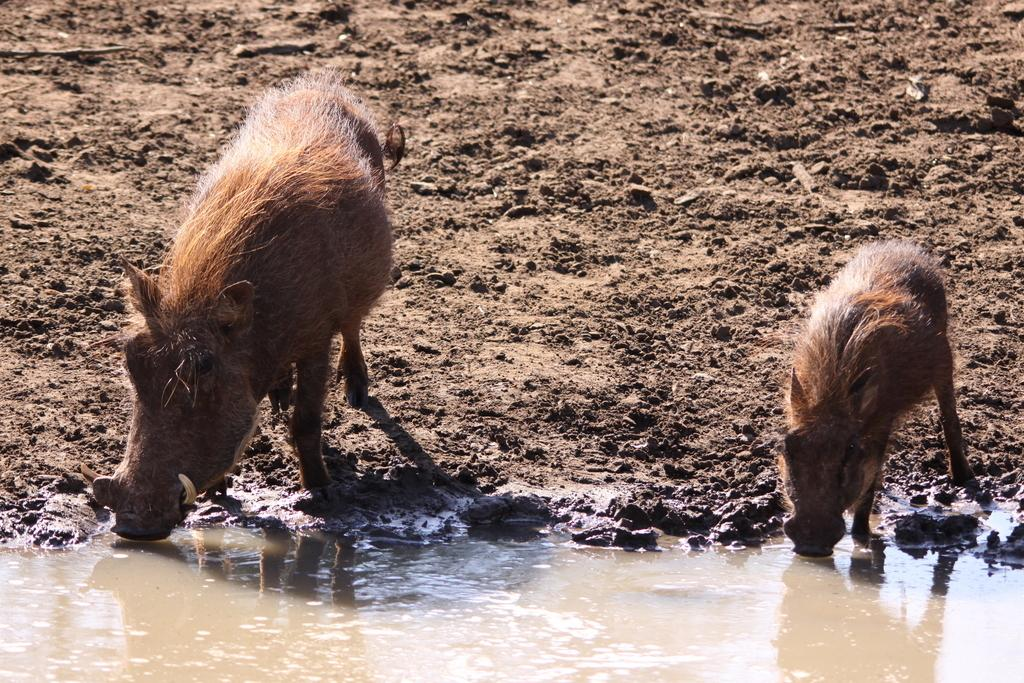What types of living organisms can be seen in the image? There are animals in the image. What is located at the bottom of the image? There is water at the bottom of the image. What type of natural environment can be seen in the background of the image? There is soil visible in the background of the image. What is the size of the chin on the animal in the image? There is no chin present on the animals in the image, as they are not human. 